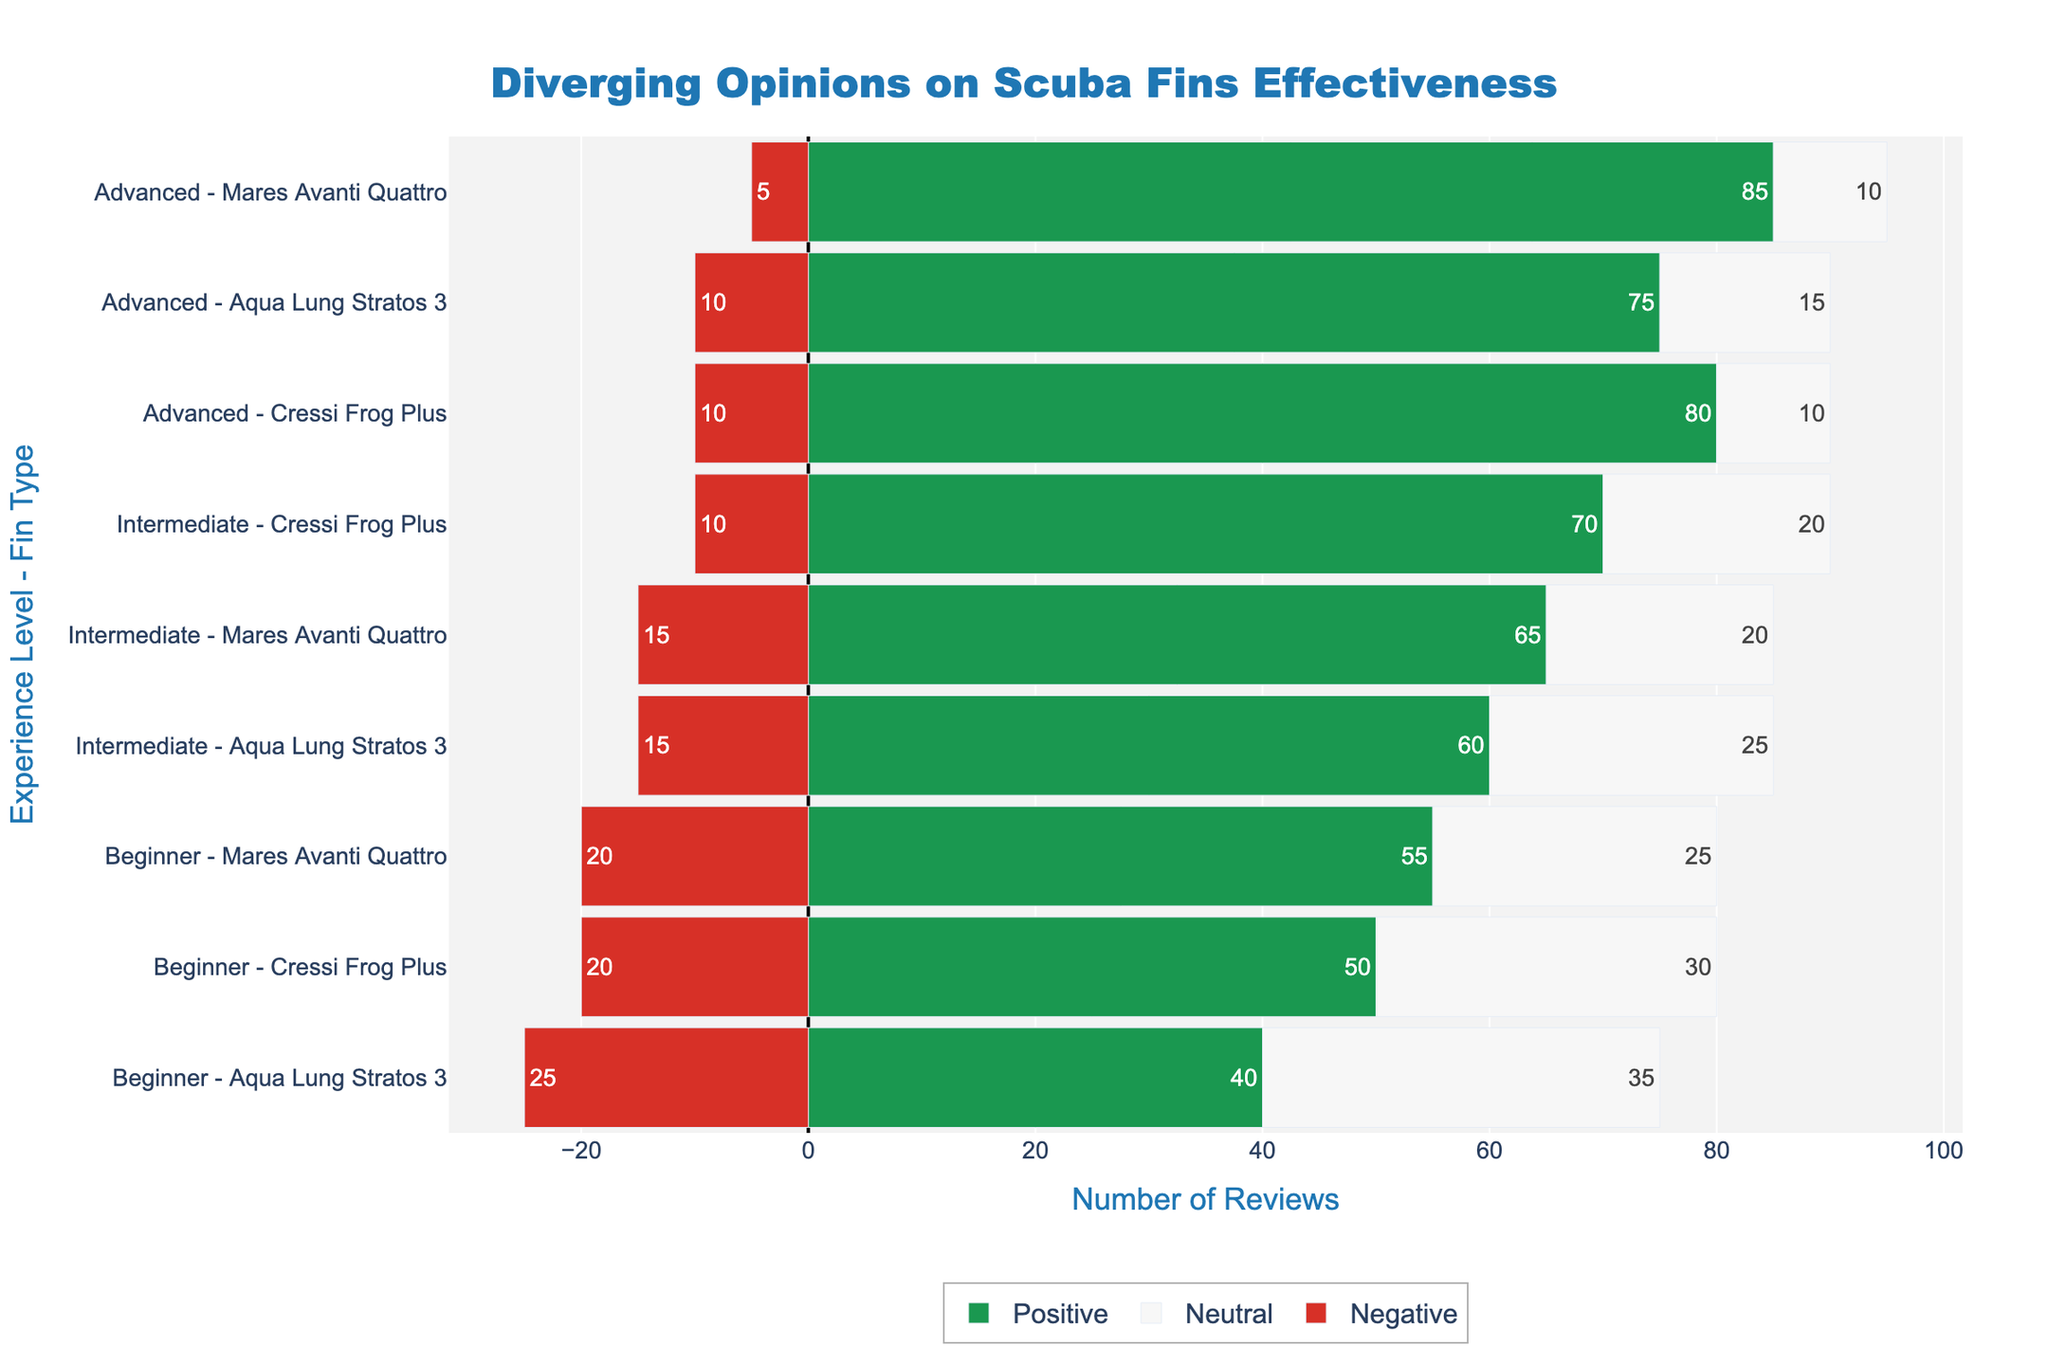What overall trend can you observe about the effectiveness of the Cressi Frog Plus fin as the experience level increases? As the experience level increases from Beginner to Advanced, the positive reviews for Cressi Frog Plus increase significantly (from 50 to 80), and negative reviews decrease (from 20 to 10). The neutral reviews also decline slightly, indicating a generally improving opinion with more experience.
Answer: Positive reviews increase; Negative reviews decrease For Mares Avanti Quattro, which experience level has the highest number of positive reviews? Mares Avanti Quattro has different positive review counts for each experience level: Beginner (55), Intermediate (65), and Advanced (85). The highest number of positive reviews is at the Advanced level.
Answer: Advanced Between Aqua Lung Stratos 3 and Cressi Frog Plus fins, which one has a higher negative review count at the Beginner experience level? At the Beginner experience level, Aqua Lung Stratos 3 has 25 negative reviews, and Cressi Frog Plus has 20 negative reviews. Therefore, Aqua Lung Stratos 3 has a higher negative review count.
Answer: Aqua Lung Stratos 3 What is the total number of reviews (sum of positive, neutral, and negative) for the Cressi Frog Plus fin at the Intermediate level? For the Cressi Frog Plus fin at the Intermediate level, the total number of reviews is the sum of positive (70), neutral (20), and negative (10) reviews. Thus, the total is 70 + 20 + 10 = 100 reviews.
Answer: 100 How does the distribution of review types for Aqua Lung Stratos 3 vary between Intermediate and Advanced levels? For Intermediate, Aqua Lung Stratos 3 has 60 positive, 25 neutral, and 15 negative reviews. For Advanced, it has 75 positive, 15 neutral, and 10 negative reviews. Comparing these, positive reviews increase (60 to 75), neutral reviews decrease (25 to 15), and negative reviews decrease (15 to 10) when moving from Intermediate to Advanced levels.
Answer: Increase in positive; Decrease in neutral and negative Which fin type at the Advanced level has the highest proportion of positive reviews and what is this proportion? At the Advanced level, three fins have different positive reviews: Cressi Frog Plus (80 out of 100 total reviews), Aqua Lung Stratos 3 (75 out of 100), and Mares Avanti Quattro (85 out of 100). Calculating the proportions, Mares Avanti Quattro has the highest at 85%.
Answer: Mares Avanti Quattro, 85% What is the difference in negative review counts between Beginner and Advanced experience levels for the Cressi Frog Plus fin? The Cressi Frog Plus fin has 20 negative reviews at the Beginner level and 10 negative reviews at the Advanced level. Therefore, the difference is 20 - 10 = 10.
Answer: 10 Which fin type shows the least change in neutral reviews between the Beginner and Intermediate levels? Comparing neutral reviews between Beginner and Intermediate: Cressi Frog Plus (30 to 20, difference = 10), Aqua Lung Stratos 3 (35 to 25, difference = 10), and Mares Avanti Quattro (25 to 20, difference = 5). Mares Avanti Quattro shows the least change (difference of 5).
Answer: Mares Avanti Quattro How do the positive review counts for Aqua Lung Stratos 3 compare among all experience levels? Aqua Lung Stratos 3 has 40 positive reviews at Beginner, 60 at Intermediate, and 75 at Advanced levels. The positive review counts increase with higher experience levels.
Answer: Increase with experience Which fin type and experience level combination has the highest number of neutral reviews? From the data, the Aqua Lung Stratos 3 at the Beginner level has the highest number of neutral reviews, which is 35.
Answer: Aqua Lung Stratos 3, Beginner 